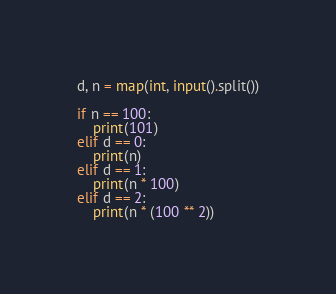<code> <loc_0><loc_0><loc_500><loc_500><_Python_>d, n = map(int, input().split())

if n == 100:
    print(101)
elif d == 0:
    print(n)
elif d == 1:
    print(n * 100)
elif d == 2:
    print(n * (100 ** 2))</code> 